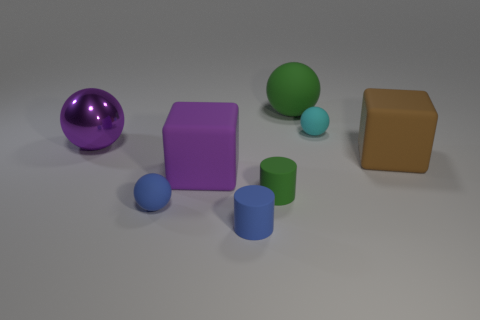Subtract 1 balls. How many balls are left? 3 Add 1 red objects. How many objects exist? 9 Subtract all cubes. How many objects are left? 6 Add 5 large rubber spheres. How many large rubber spheres are left? 6 Add 6 cyan matte objects. How many cyan matte objects exist? 7 Subtract 0 gray spheres. How many objects are left? 8 Subtract all rubber balls. Subtract all big green matte things. How many objects are left? 4 